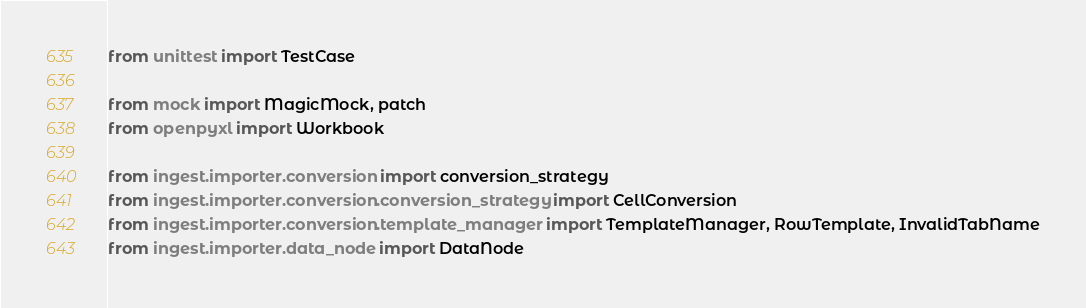<code> <loc_0><loc_0><loc_500><loc_500><_Python_>from unittest import TestCase

from mock import MagicMock, patch
from openpyxl import Workbook

from ingest.importer.conversion import conversion_strategy
from ingest.importer.conversion.conversion_strategy import CellConversion
from ingest.importer.conversion.template_manager import TemplateManager, RowTemplate, InvalidTabName
from ingest.importer.data_node import DataNode</code> 